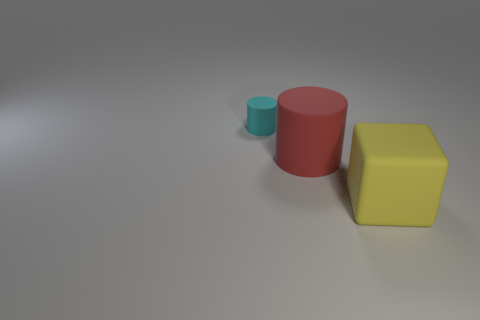Add 1 yellow matte blocks. How many objects exist? 4 Subtract all cubes. How many objects are left? 2 Subtract 0 gray balls. How many objects are left? 3 Subtract all tiny cylinders. Subtract all tiny cyan cylinders. How many objects are left? 1 Add 2 yellow things. How many yellow things are left? 3 Add 2 rubber blocks. How many rubber blocks exist? 3 